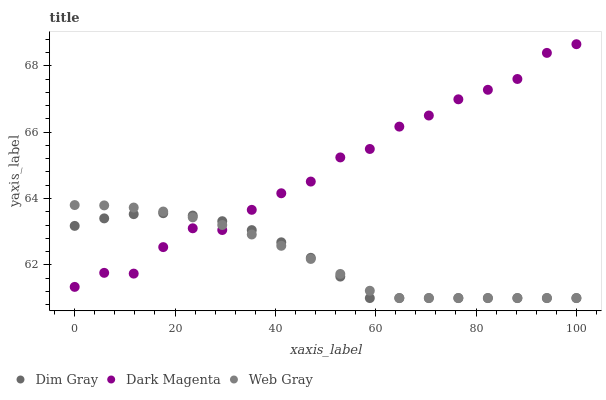Does Dim Gray have the minimum area under the curve?
Answer yes or no. Yes. Does Dark Magenta have the maximum area under the curve?
Answer yes or no. Yes. Does Web Gray have the minimum area under the curve?
Answer yes or no. No. Does Web Gray have the maximum area under the curve?
Answer yes or no. No. Is Web Gray the smoothest?
Answer yes or no. Yes. Is Dark Magenta the roughest?
Answer yes or no. Yes. Is Dark Magenta the smoothest?
Answer yes or no. No. Is Web Gray the roughest?
Answer yes or no. No. Does Dim Gray have the lowest value?
Answer yes or no. Yes. Does Dark Magenta have the lowest value?
Answer yes or no. No. Does Dark Magenta have the highest value?
Answer yes or no. Yes. Does Web Gray have the highest value?
Answer yes or no. No. Does Dim Gray intersect Dark Magenta?
Answer yes or no. Yes. Is Dim Gray less than Dark Magenta?
Answer yes or no. No. Is Dim Gray greater than Dark Magenta?
Answer yes or no. No. 